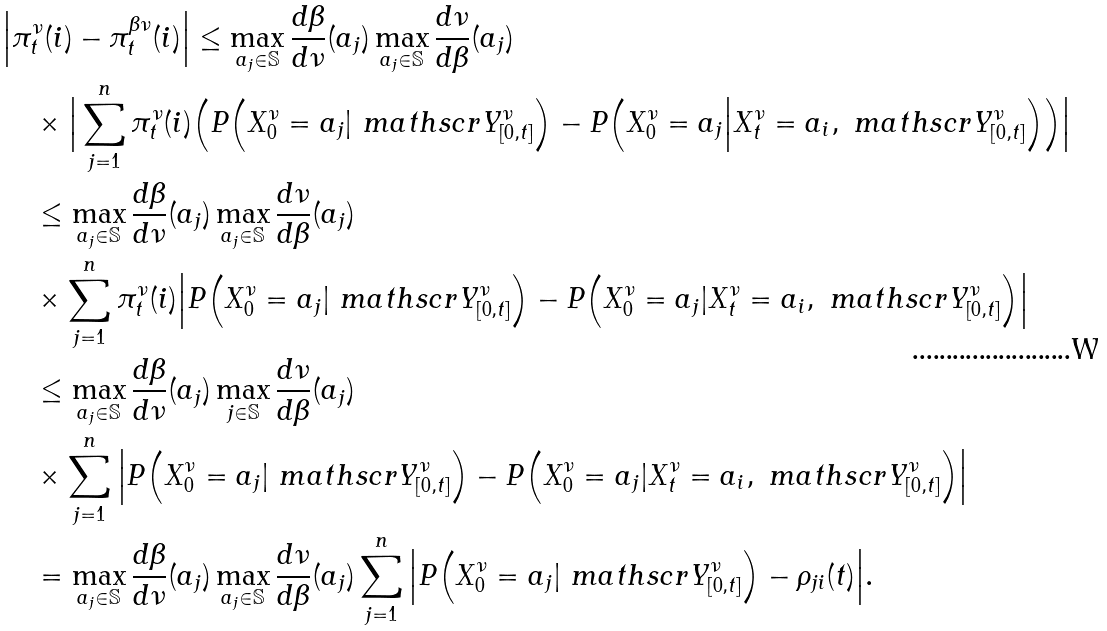<formula> <loc_0><loc_0><loc_500><loc_500>& \Big | \pi _ { t } ^ { \nu } ( i ) - \pi ^ { \beta \nu } _ { t } ( i ) \Big | \leq \max _ { a _ { j } \in \mathbb { S } } \frac { d \beta } { d \nu } ( a _ { j } ) \max _ { a _ { j } \in \mathbb { S } } \frac { d \nu } { d \beta } ( a _ { j } ) \\ & \quad \times \Big | \sum _ { j = 1 } ^ { n } \pi ^ { \nu } _ { t } ( i ) \Big ( P \Big ( X ^ { \nu } _ { 0 } = a _ { j } | \ m a t h s c r { Y } ^ { \nu } _ { [ 0 , t ] } \Big ) - P \Big ( X ^ { \nu } _ { 0 } = a _ { j } \Big | X ^ { \nu } _ { t } = a _ { i } , \ m a t h s c r { Y } ^ { \nu } _ { [ 0 , t ] } \Big ) \Big ) \Big | \\ & \quad \leq \max _ { a _ { j } \in \mathbb { S } } \frac { d \beta } { d \nu } ( a _ { j } ) \max _ { a _ { j } \in \mathbb { S } } \frac { d \nu } { d \beta } ( a _ { j } ) \\ & \quad \times \sum _ { j = 1 } ^ { n } \pi ^ { \nu } _ { t } ( i ) \Big | P \Big ( X ^ { \nu } _ { 0 } = a _ { j } | \ m a t h s c r { Y } ^ { \nu } _ { [ 0 , t ] } \Big ) - P \Big ( X ^ { \nu } _ { 0 } = a _ { j } | X ^ { \nu } _ { t } = a _ { i } , \ m a t h s c r { Y } ^ { \nu } _ { [ 0 , t ] } \Big ) \Big | \\ & \quad \leq \max _ { a _ { j } \in \mathbb { S } } \frac { d \beta } { d \nu } ( a _ { j } ) \max _ { j \in \mathbb { S } } \frac { d \nu } { d \beta } ( a _ { j } ) \\ & \quad \times \sum _ { j = 1 } ^ { n } \Big | P \Big ( X ^ { \nu } _ { 0 } = a _ { j } | \ m a t h s c r { Y } ^ { \nu } _ { [ 0 , t ] } \Big ) - P \Big ( X ^ { \nu } _ { 0 } = a _ { j } | X ^ { \nu } _ { t } = a _ { i } , \ m a t h s c r { Y } ^ { \nu } _ { [ 0 , t ] } \Big ) \Big | \\ & \quad = \max _ { a _ { j } \in \mathbb { S } } \frac { d \beta } { d \nu } ( a _ { j } ) \max _ { a _ { j } \in \mathbb { S } } \frac { d \nu } { d \beta } ( a _ { j } ) \sum _ { j = 1 } ^ { n } \Big | P \Big ( X ^ { \nu } _ { 0 } = a _ { j } | \ m a t h s c r { Y } ^ { \nu } _ { [ 0 , t ] } \Big ) - \rho _ { j i } ( t ) \Big | .</formula> 